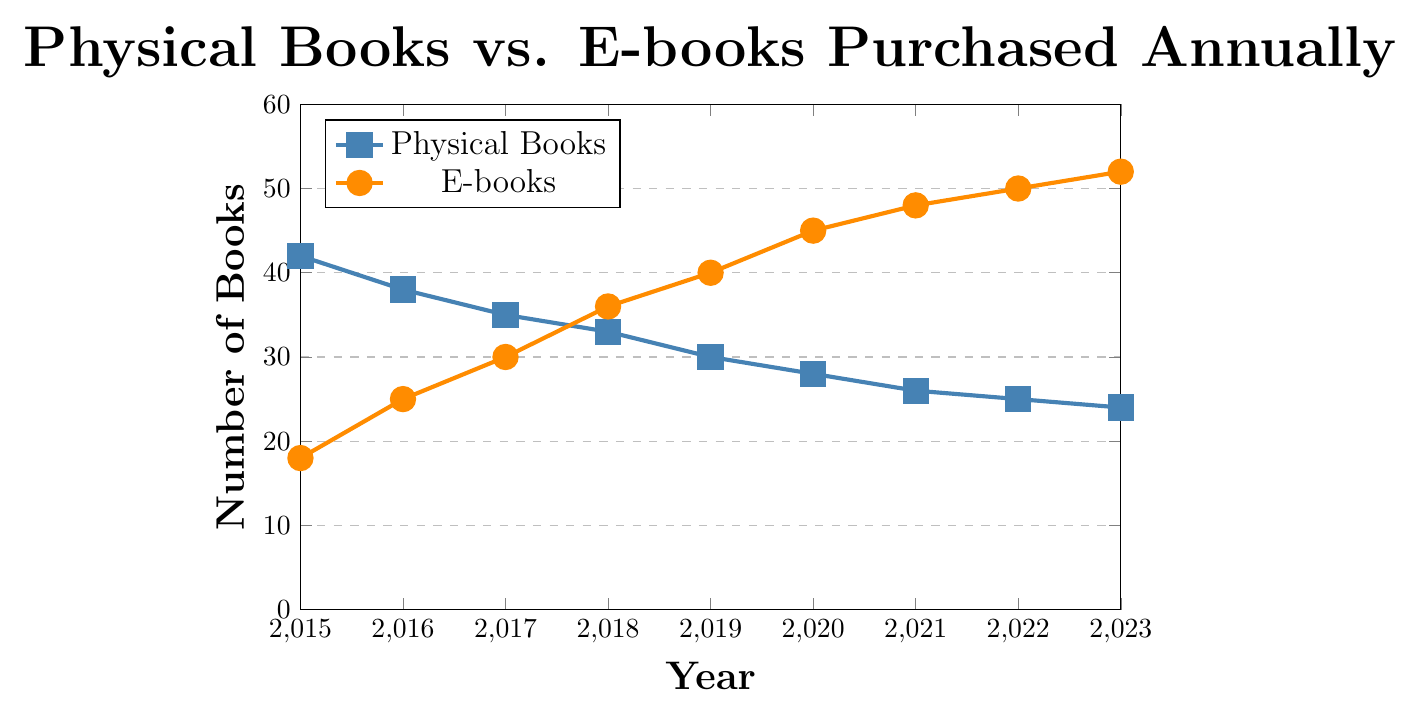What's the trend in the number of physical books purchased from 2015 to 2023? The number of physical books purchased has a decreasing trend from 42 in 2015 to 24 in 2023, indicating a steady decline in physical book purchases over the years.
Answer: Decreasing Which year had the highest number of e-books purchased? By observing the top point of the e-books graph, it peaks at 52 in the year 2023, making it the year with the highest number of e-books purchased.
Answer: 2023 What's the difference in the number of physical books and e-books purchased in 2018? In 2018, the number of physical books purchased was 33, and the number of e-books purchased was 36. The difference between these two values is 36 - 33 = 3.
Answer: 3 How many years did the number of physical books exceed e-books? By observing the plot, the number of physical books exceeded the number of e-books from 2015 to 2017. In the subsequent years, e-books purchases exceeded physical books purchases.
Answer: 3 What is the average number of e-books purchased from 2020 to 2023? The number of e-books purchased from 2020 to 2023 is 45, 48, 50, and 52 respectively. Their sum is 45 + 48 + 50 + 52 = 195, and the average is calculated as 195 / 4 = 48.75.
Answer: 48.75 Was there a year when the number of physical books and e-books purchased were equal? By examining the lines where they intersect, there is no year on the plot where the number of physical books and e-books purchased are exactly the same; hence, they did not equal at any point.
Answer: No When did the number of e-books purchased first surpass the number of physical books? By observing the intersection point of the two lines, it becomes clear that in the year 2018, the number of e-books (36) surpassed the number of physical books (33) for the first time.
Answer: 2018 What is the overall sum of physical books and e-books purchased in the year 2022? In 2022, the number of physical books purchased was 25, and the number of e-books purchased was 50. The total sum is 25 + 50 = 75.
Answer: 75 By how much did the number of physical books purchased decrease from 2015 to 2023? The number of physical books purchased in 2015 was 42, and in 2023 it was 24. The decrease is calculated as 42 - 24 = 18.
Answer: 18 